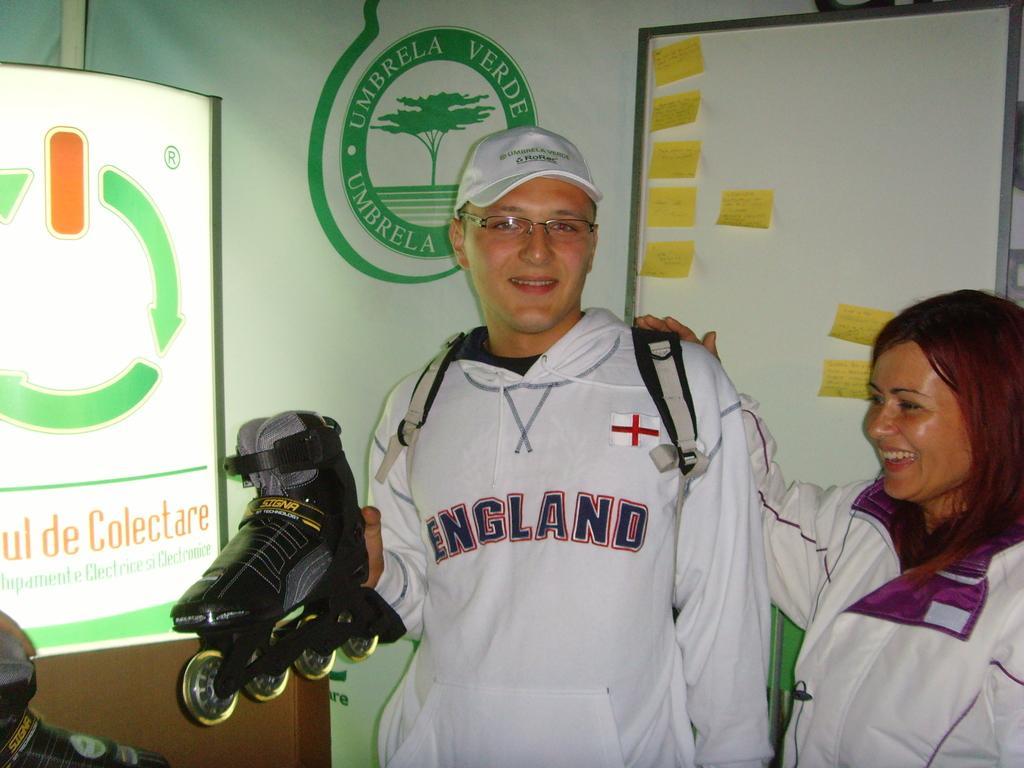Could you give a brief overview of what you see in this image? In this image we can see two people standing, a person is holding a skate shoe, in the background there is a board with some labels stick to the board and on the left side there is a banner to the wall. 